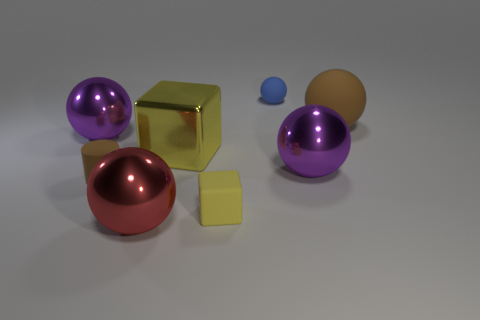What number of brown things have the same shape as the big red object?
Provide a short and direct response. 1. There is a thing that is the same color as the tiny rubber cube; what material is it?
Your answer should be very brief. Metal. Are there any other things that have the same shape as the blue thing?
Offer a very short reply. Yes. There is a large red object; what number of large brown matte spheres are in front of it?
Provide a succinct answer. 0. Is there a brown rubber thing of the same size as the red metallic object?
Your response must be concise. Yes. Are there any tiny rubber things of the same color as the big rubber ball?
Your answer should be very brief. Yes. Are there any other things that are the same size as the brown rubber ball?
Keep it short and to the point. Yes. What number of large balls are the same color as the rubber cylinder?
Provide a short and direct response. 1. Does the metal cube have the same color as the cube that is in front of the big metal cube?
Make the answer very short. Yes. How many things are big cyan objects or large purple metallic objects that are in front of the big yellow shiny block?
Offer a terse response. 1. 